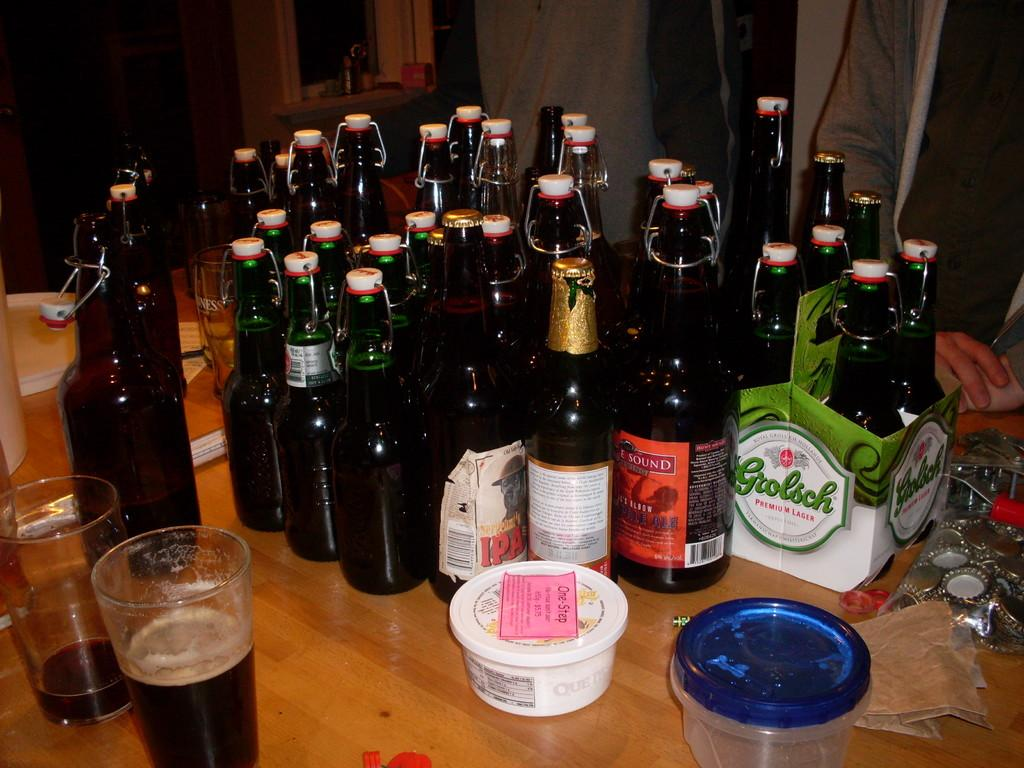<image>
Share a concise interpretation of the image provided. A four pack of Grolsch Lager is on a table along with many other beer bottles. 